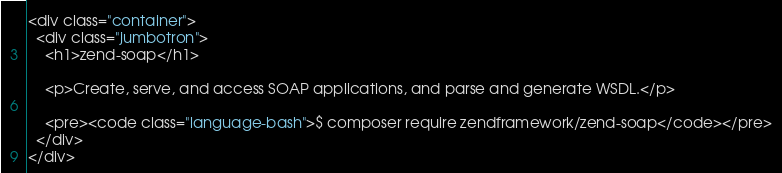<code> <loc_0><loc_0><loc_500><loc_500><_HTML_><div class="container">
  <div class="jumbotron">
    <h1>zend-soap</h1>
    
    <p>Create, serve, and access SOAP applications, and parse and generate WSDL.</p>

    <pre><code class="language-bash">$ composer require zendframework/zend-soap</code></pre>
  </div>
</div>

</code> 